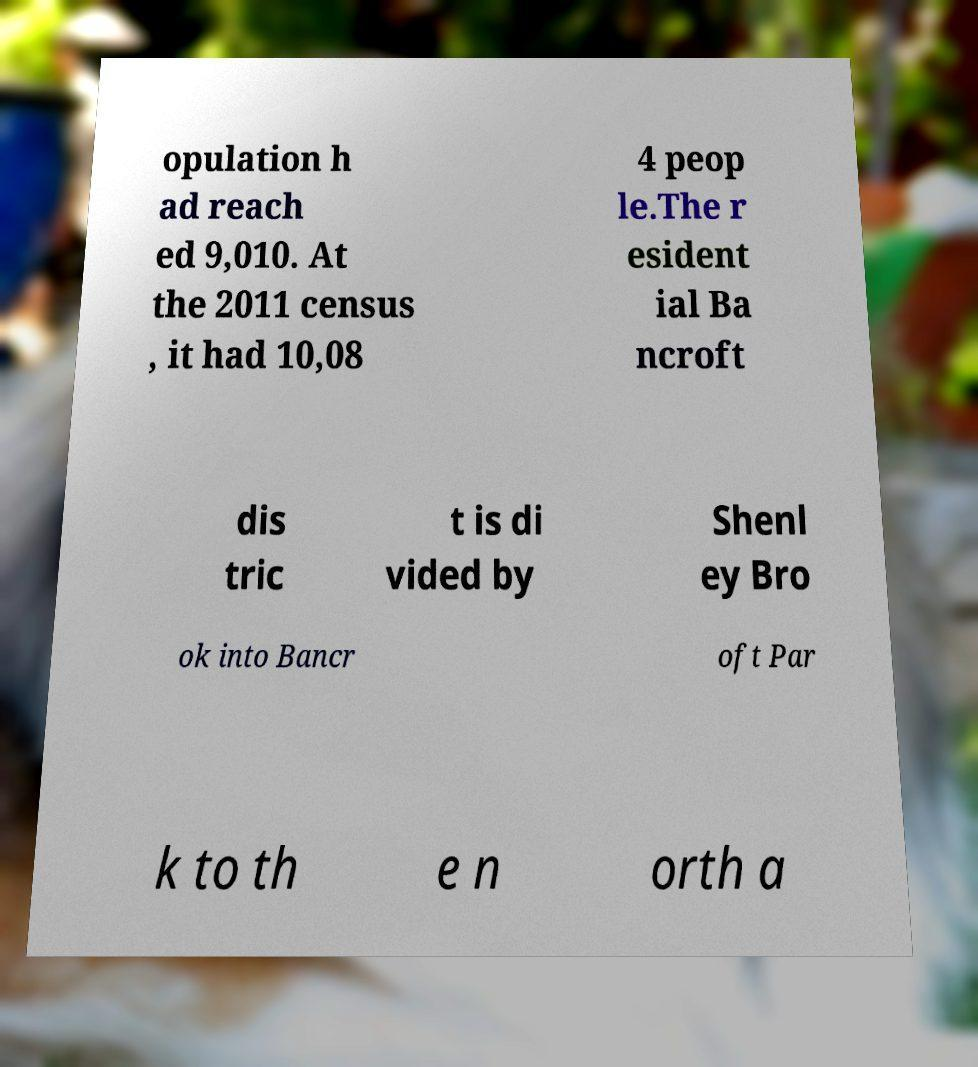Please read and relay the text visible in this image. What does it say? opulation h ad reach ed 9,010. At the 2011 census , it had 10,08 4 peop le.The r esident ial Ba ncroft dis tric t is di vided by Shenl ey Bro ok into Bancr oft Par k to th e n orth a 